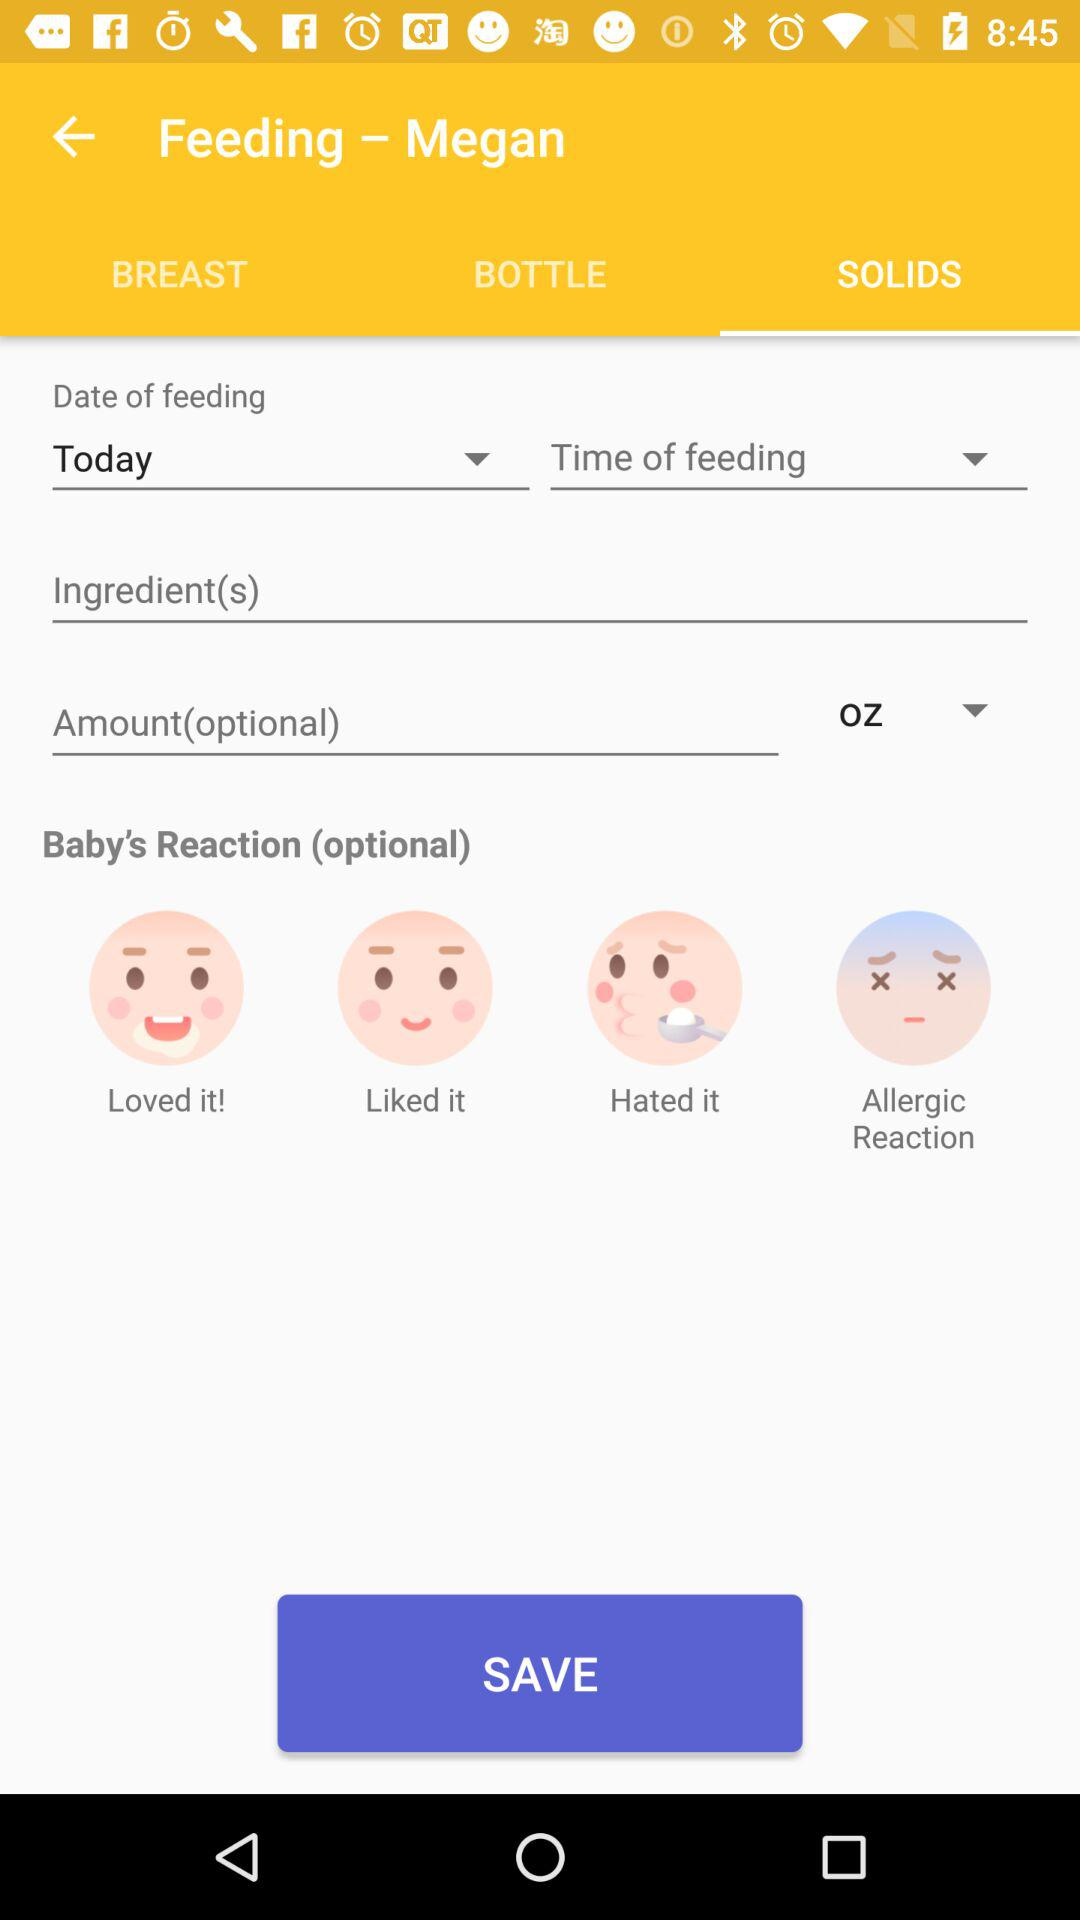How many reaction options are there?
Answer the question using a single word or phrase. 4 